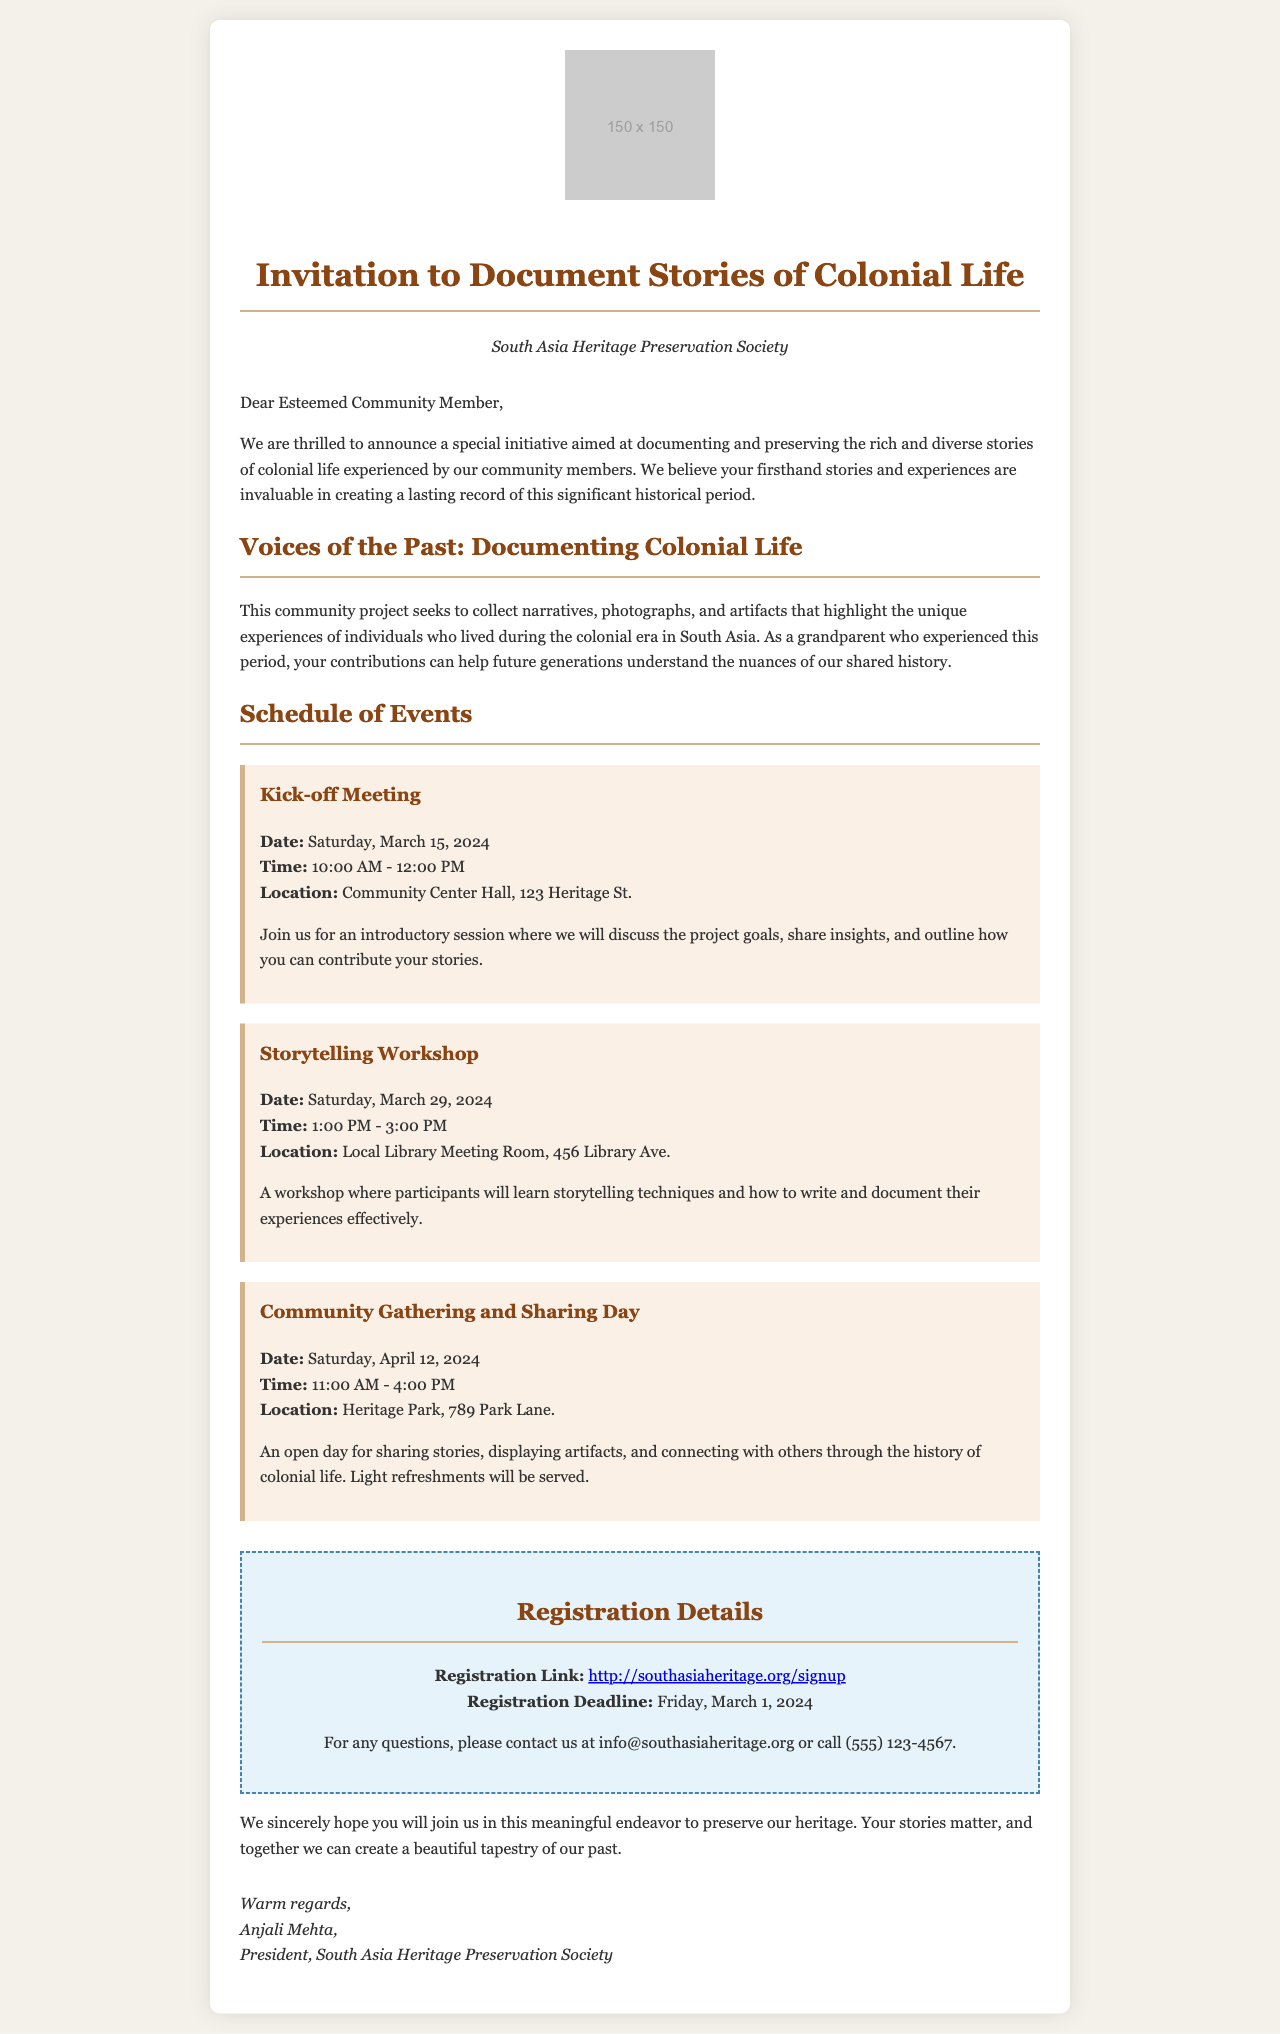what is the name of the society organizing the event? The society organizing the event is named in the header of the document.
Answer: South Asia Heritage Preservation Society what is the date of the Kick-off Meeting? The date for the Kick-off Meeting is provided in the schedule of events.
Answer: Saturday, March 15, 2024 what is the location for the Storytelling Workshop? The location for the Storytelling Workshop is specified in the event details.
Answer: Local Library Meeting Room, 456 Library Ave what is the purpose of the community project? The purpose is outlined in the introduction section of the document.
Answer: Documenting and preserving stories of colonial life how long is the Community Gathering and Sharing Day? The duration is calculated from the start and end times mentioned in the event details.
Answer: 5 hours what is the registration deadline for the events? The specific date for the registration deadline is provided in the registration section.
Answer: Friday, March 1, 2024 who is the President of the society? The President's name is included at the end of the document.
Answer: Anjali Mehta how can participants register for the project? Instructions for registration are given in the registration details section.
Answer: Through the provided registration link when is the next storytelling workshop scheduled after the Kick-off Meeting? The storytelling workshop's date is compared to the Kick-off Meeting date.
Answer: Saturday, March 29, 2024 